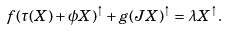<formula> <loc_0><loc_0><loc_500><loc_500>f ( \tau ( X ) + \phi X ) ^ { \uparrow } + g ( J X ) ^ { \uparrow } = \lambda X ^ { \uparrow } .</formula> 